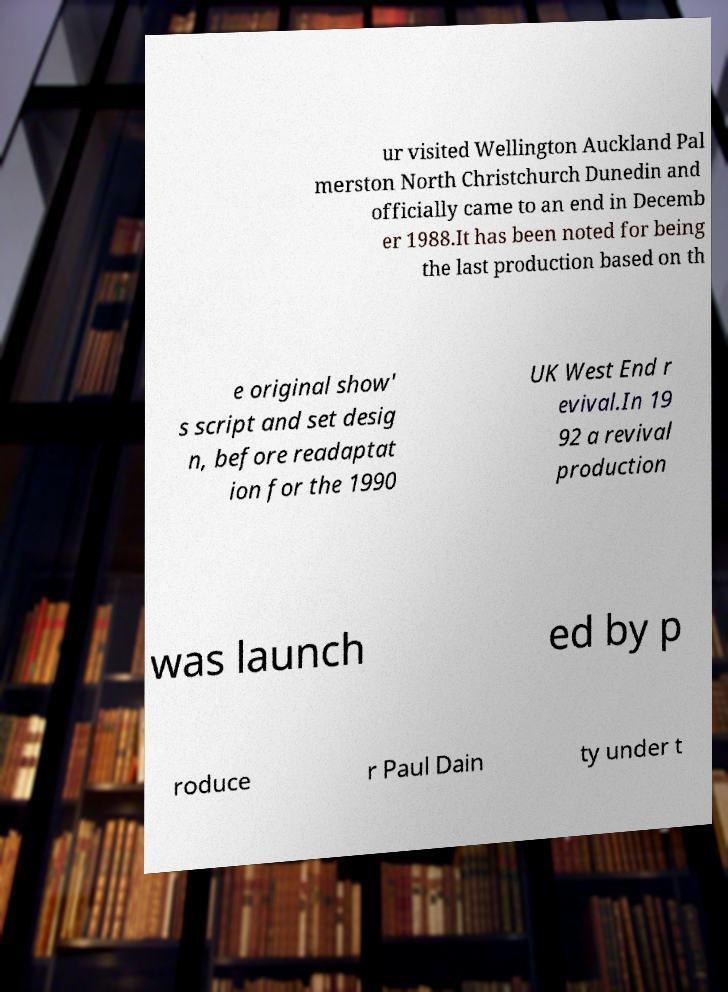Please read and relay the text visible in this image. What does it say? ur visited Wellington Auckland Pal merston North Christchurch Dunedin and officially came to an end in Decemb er 1988.It has been noted for being the last production based on th e original show' s script and set desig n, before readaptat ion for the 1990 UK West End r evival.In 19 92 a revival production was launch ed by p roduce r Paul Dain ty under t 